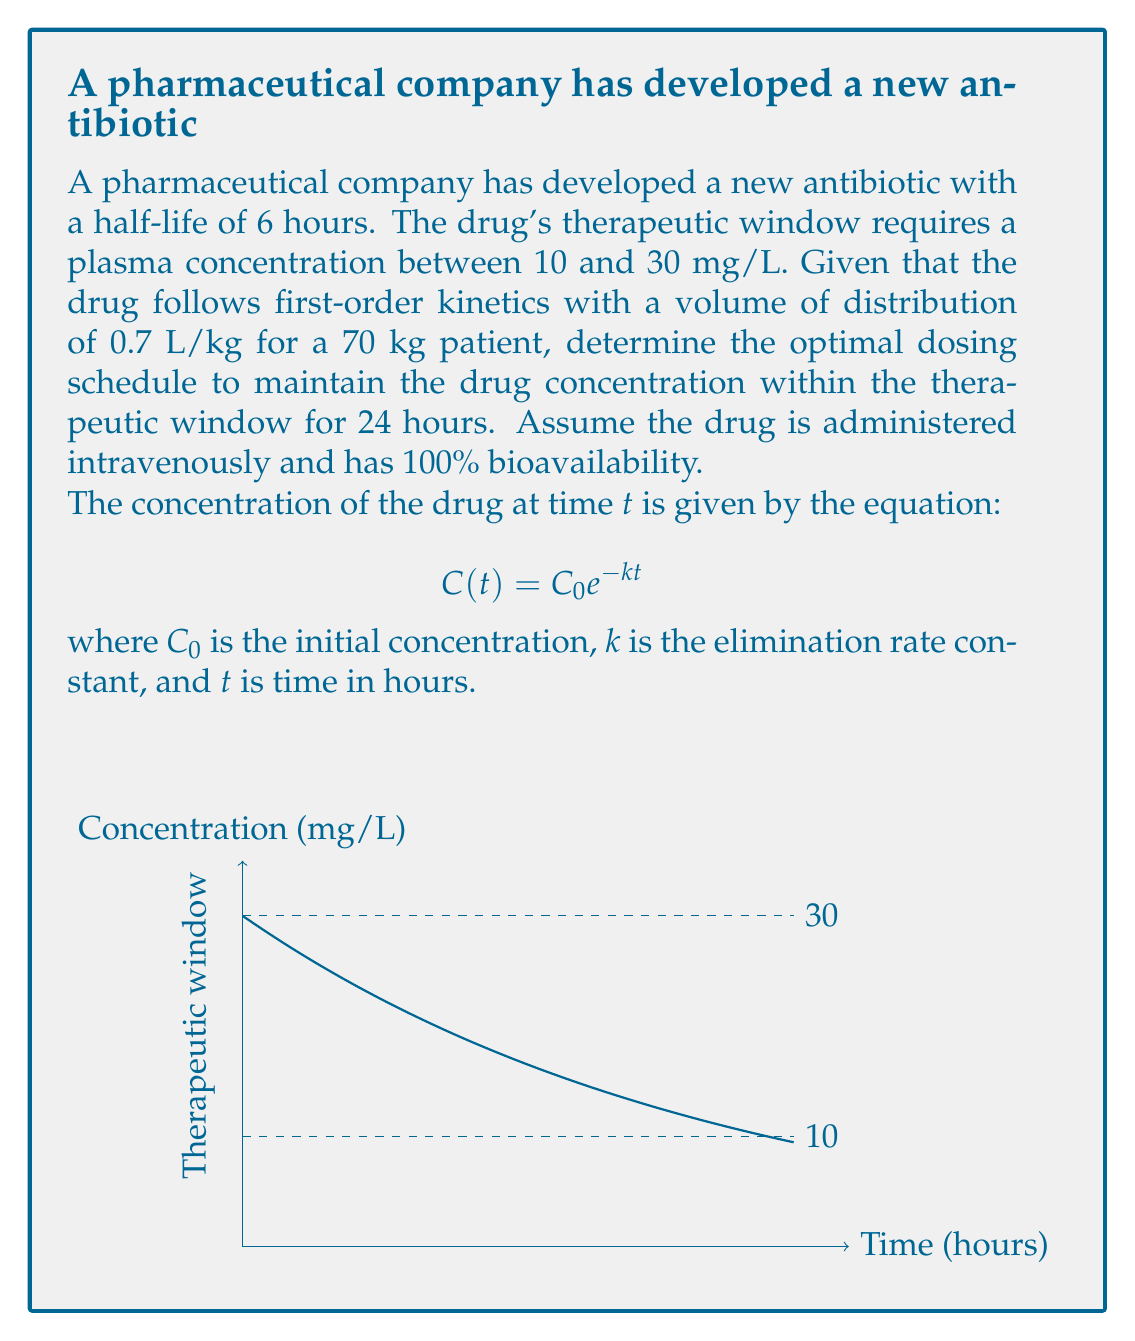Show me your answer to this math problem. Let's approach this step-by-step:

1) First, we need to calculate the elimination rate constant $k$:
   Half-life $t_{1/2} = 6$ hours
   $k = \frac{\ln(2)}{t_{1/2}} = \frac{0.693}{6} = 0.1155$ hr$^{-1}$

2) We need to find the initial concentration $C_0$ that will result in a concentration of 10 mg/L after 24 hours:
   $10 = C_0 e^{-0.1155 \cdot 24}$
   $C_0 = \frac{10}{e^{-0.1155 \cdot 24}} = 30.0$ mg/L

3) Now we need to calculate the dose required to achieve this initial concentration:
   Dose = $C_0 \cdot V_d$, where $V_d$ is the volume of distribution
   $V_d = 0.7$ L/kg $\cdot 70$ kg $= 49$ L
   Dose = $30.0$ mg/L $\cdot 49$ L $= 1470$ mg

4) To maintain the concentration within the therapeutic window, we need to administer this dose every 24 hours.

5) Let's verify that this dosing schedule keeps the concentration below 30 mg/L:
   At $t = 0$, $C(0) = 30.0$ mg/L (just at the upper limit)
   At $t = 24$, $C(24) = 30.0 e^{-0.1155 \cdot 24} = 10.0$ mg/L (just at the lower limit)

Therefore, administering 1470 mg every 24 hours will maintain the drug concentration within the therapeutic window.
Answer: Administer 1470 mg intravenously every 24 hours. 